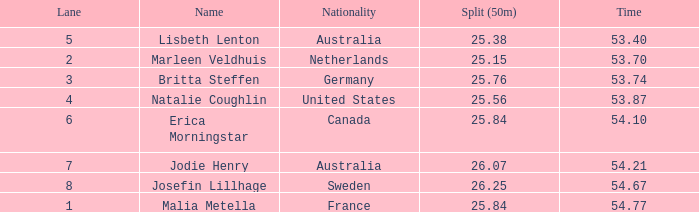What is the total sum of 50m splits for josefin lillhage in lanes above 8? None. 